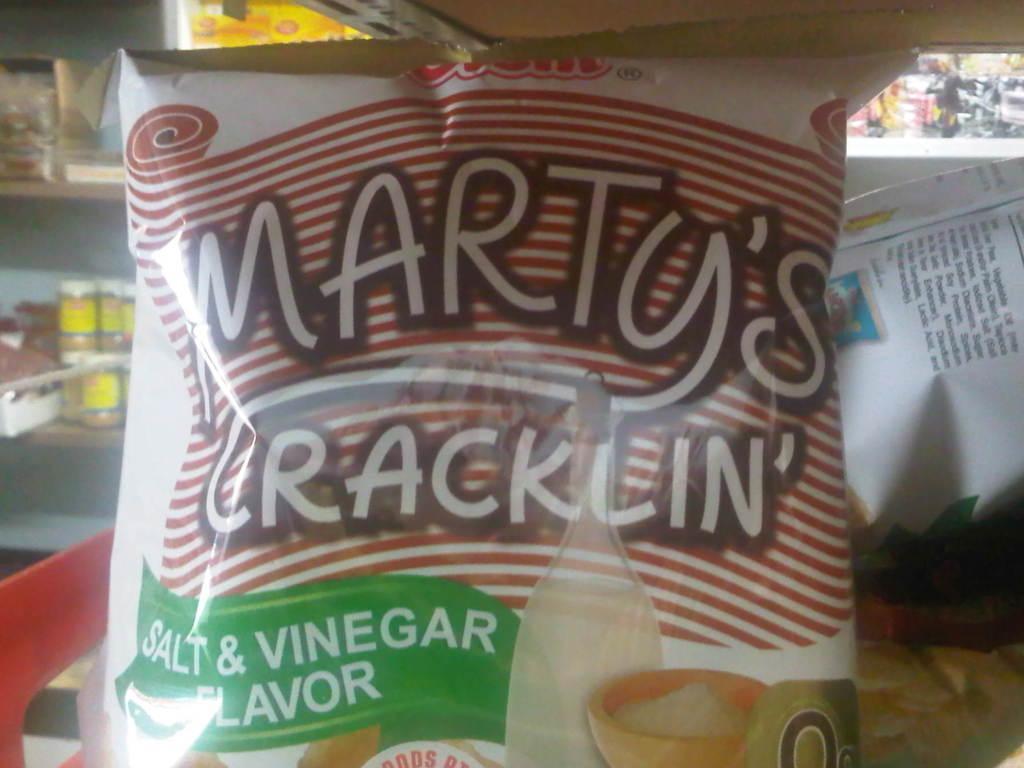In one or two sentences, can you explain what this image depicts? In the center of this picture we can see a bag of food item on which we can see the text and some pictures. In the background we can see the cabinets containing bottles and many other objects. 